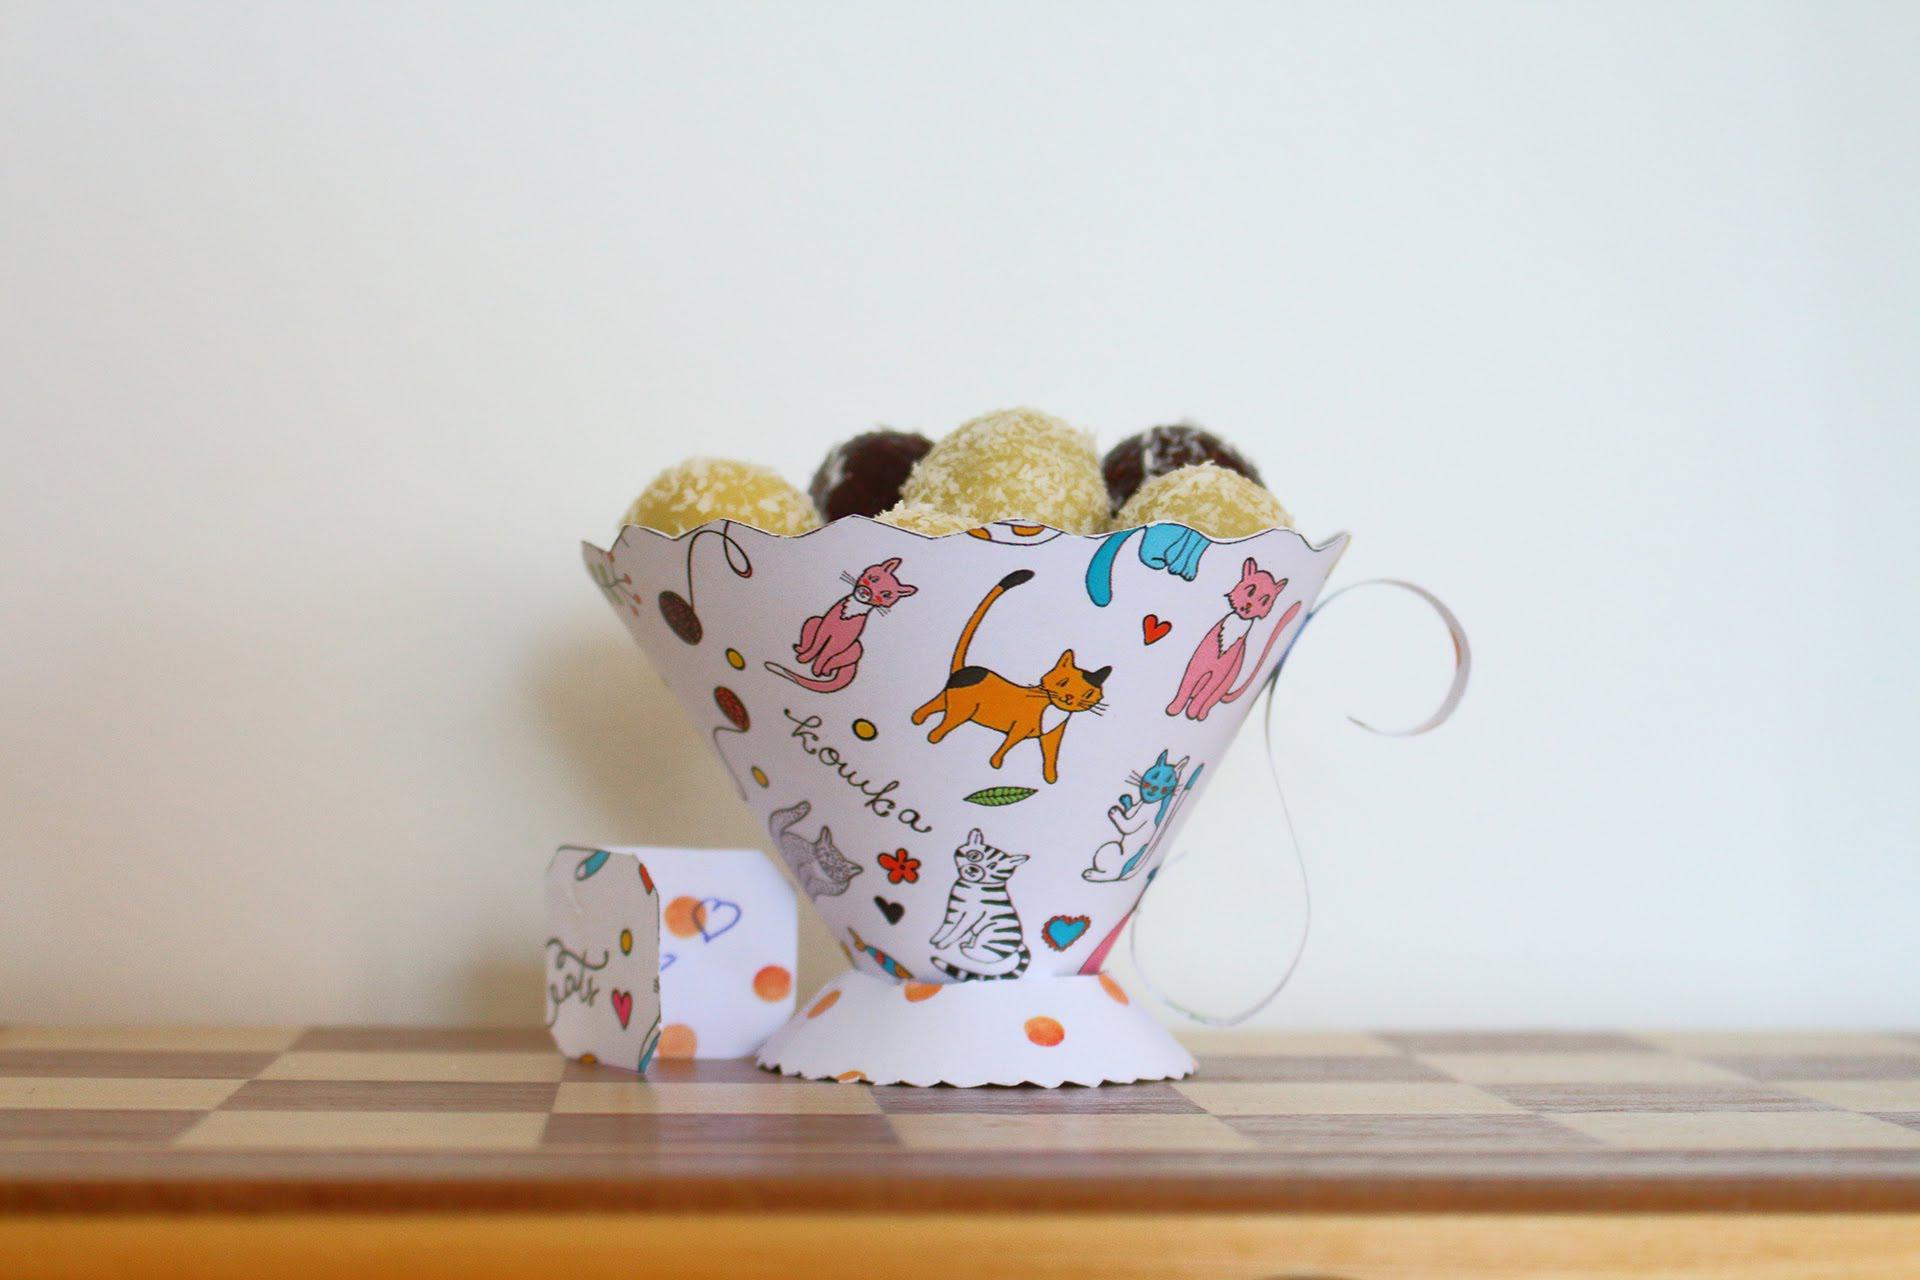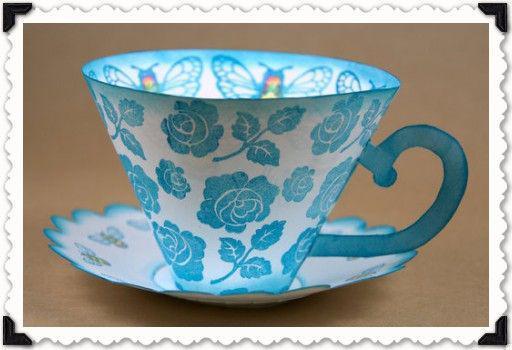The first image is the image on the left, the second image is the image on the right. Considering the images on both sides, is "There is a solid white cup." valid? Answer yes or no. No. The first image is the image on the left, the second image is the image on the right. Analyze the images presented: Is the assertion "An image shows at least two stacks of at least three cups on matching saucers, featuring different solid colors, polka dots, and scalloped edges." valid? Answer yes or no. No. 